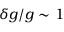Convert formula to latex. <formula><loc_0><loc_0><loc_500><loc_500>\delta g / g \sim 1 \</formula> 